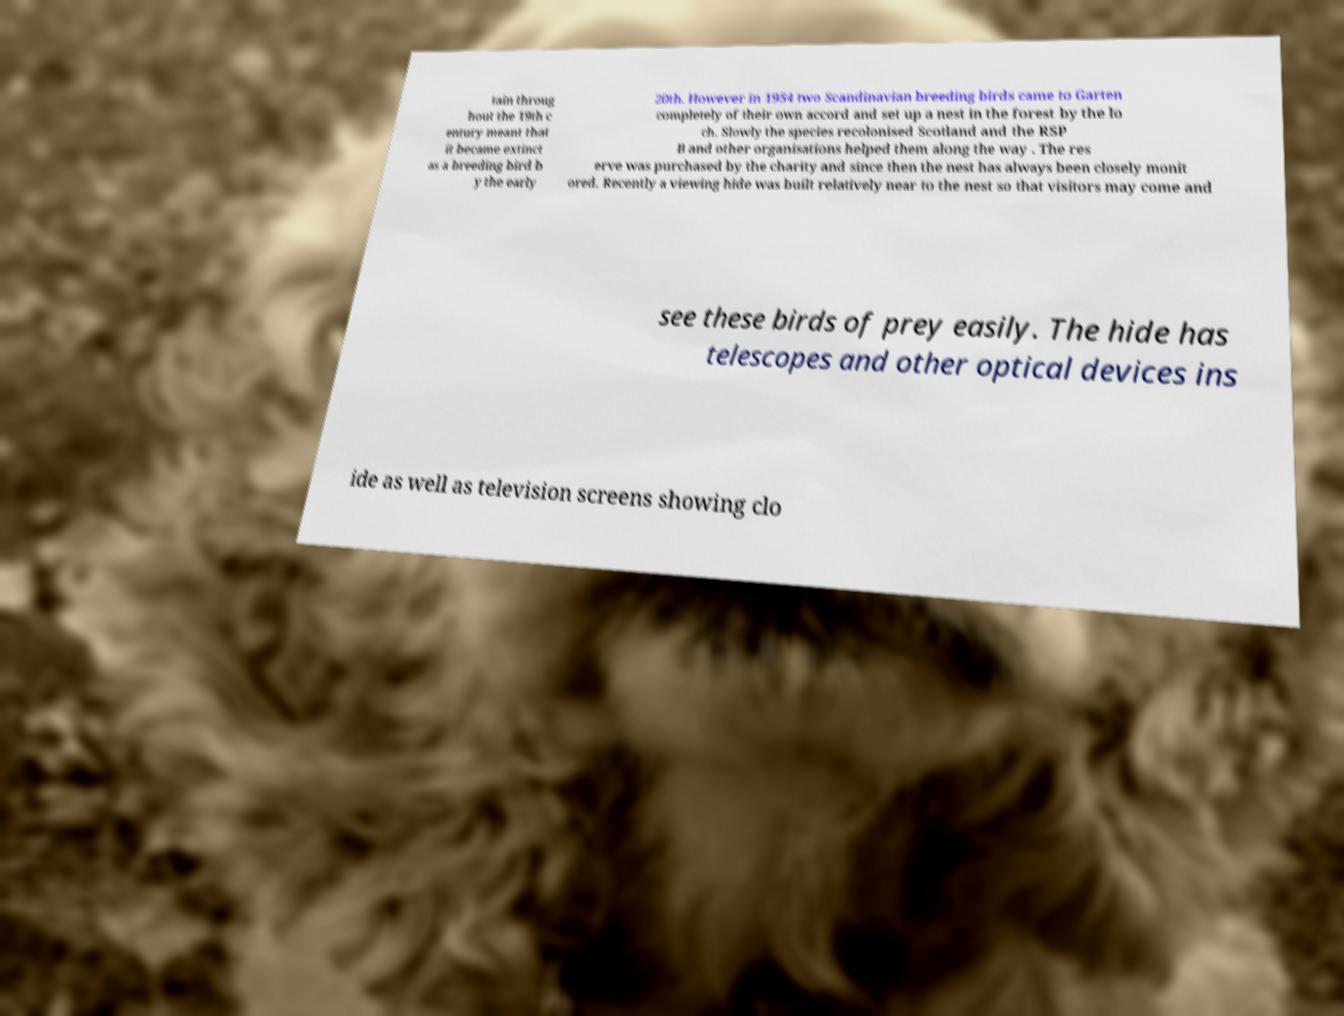Please identify and transcribe the text found in this image. tain throug hout the 19th c entury meant that it became extinct as a breeding bird b y the early 20th. However in 1954 two Scandinavian breeding birds came to Garten completely of their own accord and set up a nest in the forest by the lo ch. Slowly the species recolonised Scotland and the RSP B and other organisations helped them along the way . The res erve was purchased by the charity and since then the nest has always been closely monit ored. Recently a viewing hide was built relatively near to the nest so that visitors may come and see these birds of prey easily. The hide has telescopes and other optical devices ins ide as well as television screens showing clo 